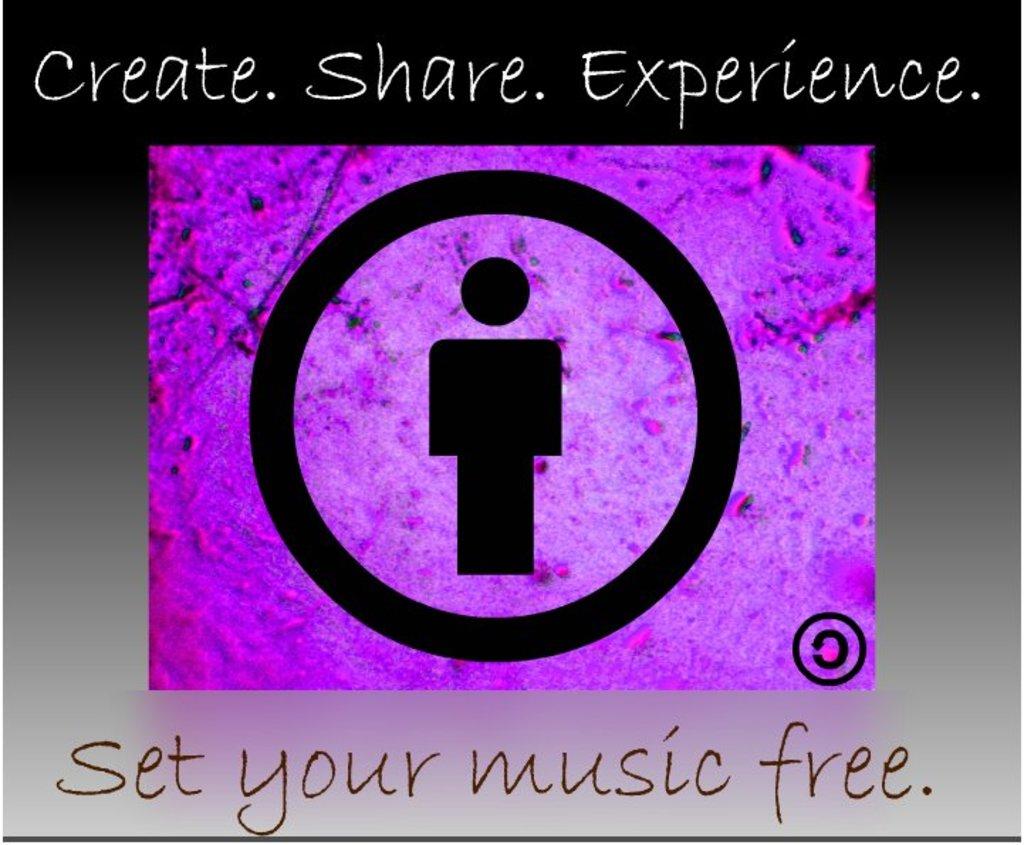What should we set free?
Offer a terse response. Music. What are the words on top of the picture?
Provide a short and direct response. Create. share. experience. 